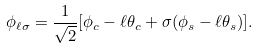<formula> <loc_0><loc_0><loc_500><loc_500>\phi _ { \ell \sigma } = \frac { 1 } { \sqrt { 2 } } [ \phi _ { c } - \ell \theta _ { c } + \sigma ( \phi _ { s } - \ell \theta _ { s } ) ] .</formula> 